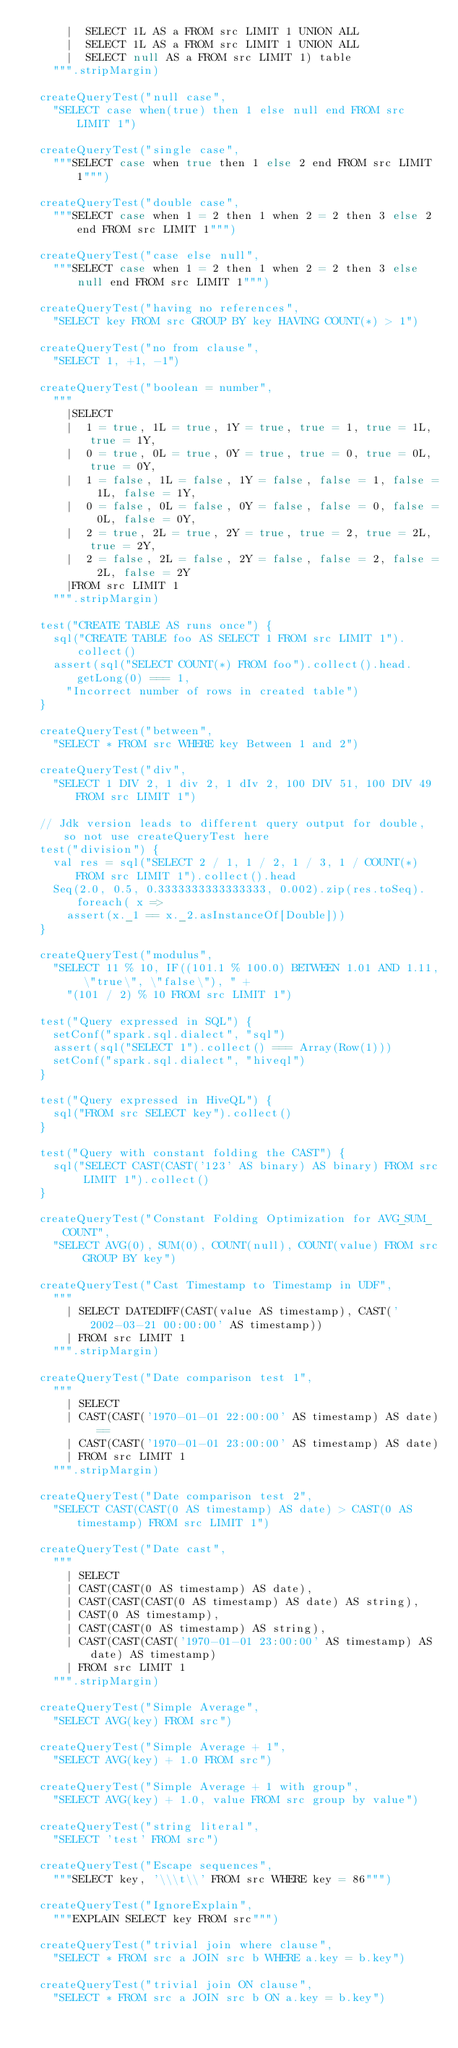<code> <loc_0><loc_0><loc_500><loc_500><_Scala_>      |  SELECT 1L AS a FROM src LIMIT 1 UNION ALL
      |  SELECT 1L AS a FROM src LIMIT 1 UNION ALL
      |  SELECT null AS a FROM src LIMIT 1) table
    """.stripMargin)

  createQueryTest("null case",
    "SELECT case when(true) then 1 else null end FROM src LIMIT 1")

  createQueryTest("single case",
    """SELECT case when true then 1 else 2 end FROM src LIMIT 1""")

  createQueryTest("double case",
    """SELECT case when 1 = 2 then 1 when 2 = 2 then 3 else 2 end FROM src LIMIT 1""")

  createQueryTest("case else null",
    """SELECT case when 1 = 2 then 1 when 2 = 2 then 3 else null end FROM src LIMIT 1""")

  createQueryTest("having no references",
    "SELECT key FROM src GROUP BY key HAVING COUNT(*) > 1")

  createQueryTest("no from clause",
    "SELECT 1, +1, -1")

  createQueryTest("boolean = number",
    """
      |SELECT
      |  1 = true, 1L = true, 1Y = true, true = 1, true = 1L, true = 1Y,
      |  0 = true, 0L = true, 0Y = true, true = 0, true = 0L, true = 0Y,
      |  1 = false, 1L = false, 1Y = false, false = 1, false = 1L, false = 1Y,
      |  0 = false, 0L = false, 0Y = false, false = 0, false = 0L, false = 0Y,
      |  2 = true, 2L = true, 2Y = true, true = 2, true = 2L, true = 2Y,
      |  2 = false, 2L = false, 2Y = false, false = 2, false = 2L, false = 2Y
      |FROM src LIMIT 1
    """.stripMargin)

  test("CREATE TABLE AS runs once") {
    sql("CREATE TABLE foo AS SELECT 1 FROM src LIMIT 1").collect()
    assert(sql("SELECT COUNT(*) FROM foo").collect().head.getLong(0) === 1,
      "Incorrect number of rows in created table")
  }

  createQueryTest("between",
    "SELECT * FROM src WHERE key Between 1 and 2")

  createQueryTest("div",
    "SELECT 1 DIV 2, 1 div 2, 1 dIv 2, 100 DIV 51, 100 DIV 49 FROM src LIMIT 1")

  // Jdk version leads to different query output for double, so not use createQueryTest here
  test("division") {
    val res = sql("SELECT 2 / 1, 1 / 2, 1 / 3, 1 / COUNT(*) FROM src LIMIT 1").collect().head
    Seq(2.0, 0.5, 0.3333333333333333, 0.002).zip(res.toSeq).foreach( x =>
      assert(x._1 == x._2.asInstanceOf[Double]))
  }

  createQueryTest("modulus",
    "SELECT 11 % 10, IF((101.1 % 100.0) BETWEEN 1.01 AND 1.11, \"true\", \"false\"), " +
      "(101 / 2) % 10 FROM src LIMIT 1")

  test("Query expressed in SQL") {
    setConf("spark.sql.dialect", "sql")
    assert(sql("SELECT 1").collect() === Array(Row(1)))
    setConf("spark.sql.dialect", "hiveql")
  }

  test("Query expressed in HiveQL") {
    sql("FROM src SELECT key").collect()
  }

  test("Query with constant folding the CAST") {
    sql("SELECT CAST(CAST('123' AS binary) AS binary) FROM src LIMIT 1").collect()
  }

  createQueryTest("Constant Folding Optimization for AVG_SUM_COUNT",
    "SELECT AVG(0), SUM(0), COUNT(null), COUNT(value) FROM src GROUP BY key")

  createQueryTest("Cast Timestamp to Timestamp in UDF",
    """
      | SELECT DATEDIFF(CAST(value AS timestamp), CAST('2002-03-21 00:00:00' AS timestamp))
      | FROM src LIMIT 1
    """.stripMargin)

  createQueryTest("Date comparison test 1",
    """
      | SELECT
      | CAST(CAST('1970-01-01 22:00:00' AS timestamp) AS date) ==
      | CAST(CAST('1970-01-01 23:00:00' AS timestamp) AS date)
      | FROM src LIMIT 1
    """.stripMargin)

  createQueryTest("Date comparison test 2",
    "SELECT CAST(CAST(0 AS timestamp) AS date) > CAST(0 AS timestamp) FROM src LIMIT 1")

  createQueryTest("Date cast",
    """
      | SELECT
      | CAST(CAST(0 AS timestamp) AS date),
      | CAST(CAST(CAST(0 AS timestamp) AS date) AS string),
      | CAST(0 AS timestamp),
      | CAST(CAST(0 AS timestamp) AS string),
      | CAST(CAST(CAST('1970-01-01 23:00:00' AS timestamp) AS date) AS timestamp)
      | FROM src LIMIT 1
    """.stripMargin)

  createQueryTest("Simple Average",
    "SELECT AVG(key) FROM src")

  createQueryTest("Simple Average + 1",
    "SELECT AVG(key) + 1.0 FROM src")

  createQueryTest("Simple Average + 1 with group",
    "SELECT AVG(key) + 1.0, value FROM src group by value")

  createQueryTest("string literal",
    "SELECT 'test' FROM src")

  createQueryTest("Escape sequences",
    """SELECT key, '\\\t\\' FROM src WHERE key = 86""")

  createQueryTest("IgnoreExplain",
    """EXPLAIN SELECT key FROM src""")

  createQueryTest("trivial join where clause",
    "SELECT * FROM src a JOIN src b WHERE a.key = b.key")

  createQueryTest("trivial join ON clause",
    "SELECT * FROM src a JOIN src b ON a.key = b.key")
</code> 